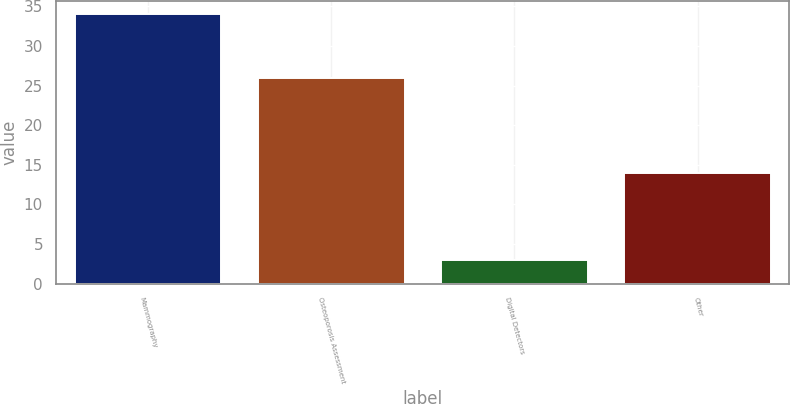Convert chart. <chart><loc_0><loc_0><loc_500><loc_500><bar_chart><fcel>Mammography<fcel>Osteoporosis Assessment<fcel>Digital Detectors<fcel>Other<nl><fcel>34<fcel>26<fcel>3<fcel>14<nl></chart> 